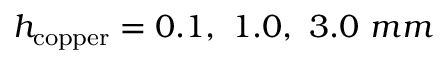Convert formula to latex. <formula><loc_0><loc_0><loc_500><loc_500>h _ { c o p p e r } = 0 . 1 , \ 1 . 0 , \ 3 . 0 \ m m</formula> 